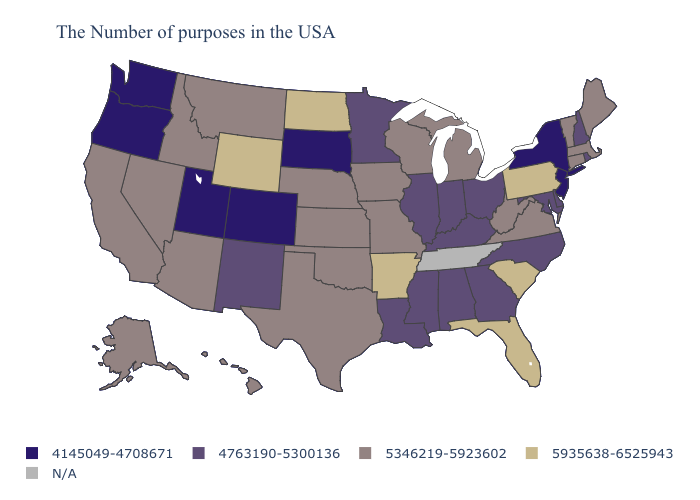Name the states that have a value in the range 5346219-5923602?
Quick response, please. Maine, Massachusetts, Vermont, Connecticut, Virginia, West Virginia, Michigan, Wisconsin, Missouri, Iowa, Kansas, Nebraska, Oklahoma, Texas, Montana, Arizona, Idaho, Nevada, California, Alaska, Hawaii. Does the map have missing data?
Concise answer only. Yes. What is the lowest value in the MidWest?
Be succinct. 4145049-4708671. Among the states that border New Jersey , does New York have the lowest value?
Concise answer only. Yes. What is the value of Wyoming?
Short answer required. 5935638-6525943. Which states have the highest value in the USA?
Concise answer only. Pennsylvania, South Carolina, Florida, Arkansas, North Dakota, Wyoming. Does South Dakota have the lowest value in the MidWest?
Answer briefly. Yes. What is the highest value in the USA?
Quick response, please. 5935638-6525943. What is the value of Alaska?
Give a very brief answer. 5346219-5923602. Which states have the lowest value in the South?
Answer briefly. Delaware, Maryland, North Carolina, Georgia, Kentucky, Alabama, Mississippi, Louisiana. What is the lowest value in the West?
Quick response, please. 4145049-4708671. What is the highest value in the USA?
Write a very short answer. 5935638-6525943. What is the value of Kansas?
Give a very brief answer. 5346219-5923602. Name the states that have a value in the range 5346219-5923602?
Be succinct. Maine, Massachusetts, Vermont, Connecticut, Virginia, West Virginia, Michigan, Wisconsin, Missouri, Iowa, Kansas, Nebraska, Oklahoma, Texas, Montana, Arizona, Idaho, Nevada, California, Alaska, Hawaii. What is the highest value in states that border South Dakota?
Answer briefly. 5935638-6525943. 